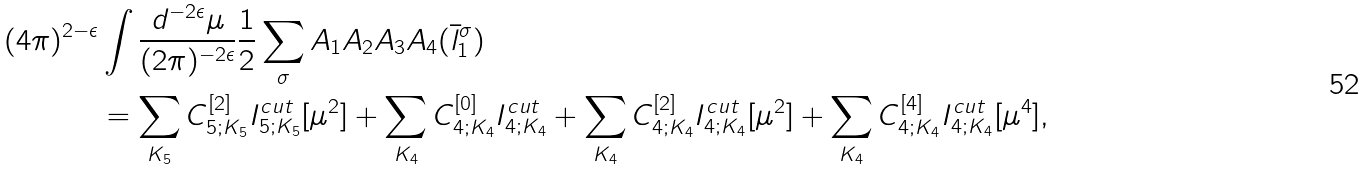Convert formula to latex. <formula><loc_0><loc_0><loc_500><loc_500>( 4 \pi ) ^ { 2 - \epsilon } & \int \frac { d ^ { - 2 \epsilon } \mu } { ( 2 \pi ) ^ { - 2 \epsilon } } \frac { 1 } { 2 } \sum _ { \sigma } A _ { 1 } A _ { 2 } A _ { 3 } A _ { 4 } ( \bar { l } _ { 1 } ^ { \sigma } ) \\ & = \sum _ { K _ { 5 } } C _ { 5 ; K _ { 5 } } ^ { [ 2 ] } I _ { 5 ; K _ { 5 } } ^ { c u t } [ \mu ^ { 2 } ] + \sum _ { K _ { 4 } } C _ { 4 ; K _ { 4 } } ^ { [ 0 ] } I _ { 4 ; K _ { 4 } } ^ { c u t } + \sum _ { K _ { 4 } } C _ { 4 ; K _ { 4 } } ^ { [ 2 ] } I _ { 4 ; K _ { 4 } } ^ { c u t } [ \mu ^ { 2 } ] + \sum _ { K _ { 4 } } C _ { 4 ; K _ { 4 } } ^ { [ 4 ] } I _ { 4 ; K _ { 4 } } ^ { c u t } [ \mu ^ { 4 } ] ,</formula> 